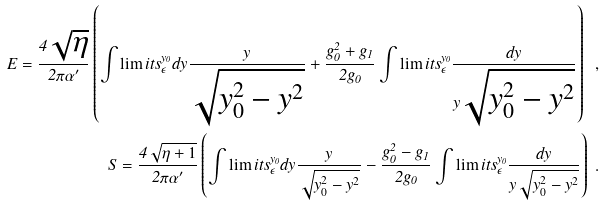Convert formula to latex. <formula><loc_0><loc_0><loc_500><loc_500>\label l { 2 0 } E = \frac { 4 \sqrt { \eta } } { 2 \pi \alpha ^ { \prime } } \left ( \int \lim i t s ^ { y _ { 0 } } _ { \epsilon } d y { \frac { y } { \sqrt { y _ { 0 } ^ { 2 } - y ^ { 2 } } } } + \frac { g _ { 0 } ^ { 2 } + g _ { 1 } } { 2 g _ { 0 } } \int \lim i t s ^ { y _ { 0 } } _ { \epsilon } { \frac { d y } { y \sqrt { y _ { 0 } ^ { 2 } - y ^ { 2 } } } } \right ) \ , \\ S = \frac { 4 \sqrt { \eta + 1 } } { 2 \pi \alpha ^ { \prime } } \left ( \int \lim i t s ^ { y _ { 0 } } _ { \epsilon } d y { \frac { y } { \sqrt { y _ { 0 } ^ { 2 } - y ^ { 2 } } } } - \frac { g _ { 0 } ^ { 2 } - g _ { 1 } } { 2 g _ { 0 } } \int \lim i t s ^ { y _ { 0 } } _ { \epsilon } { \frac { d y } { y \sqrt { y _ { 0 } ^ { 2 } - y ^ { 2 } } } } \right ) \ .</formula> 